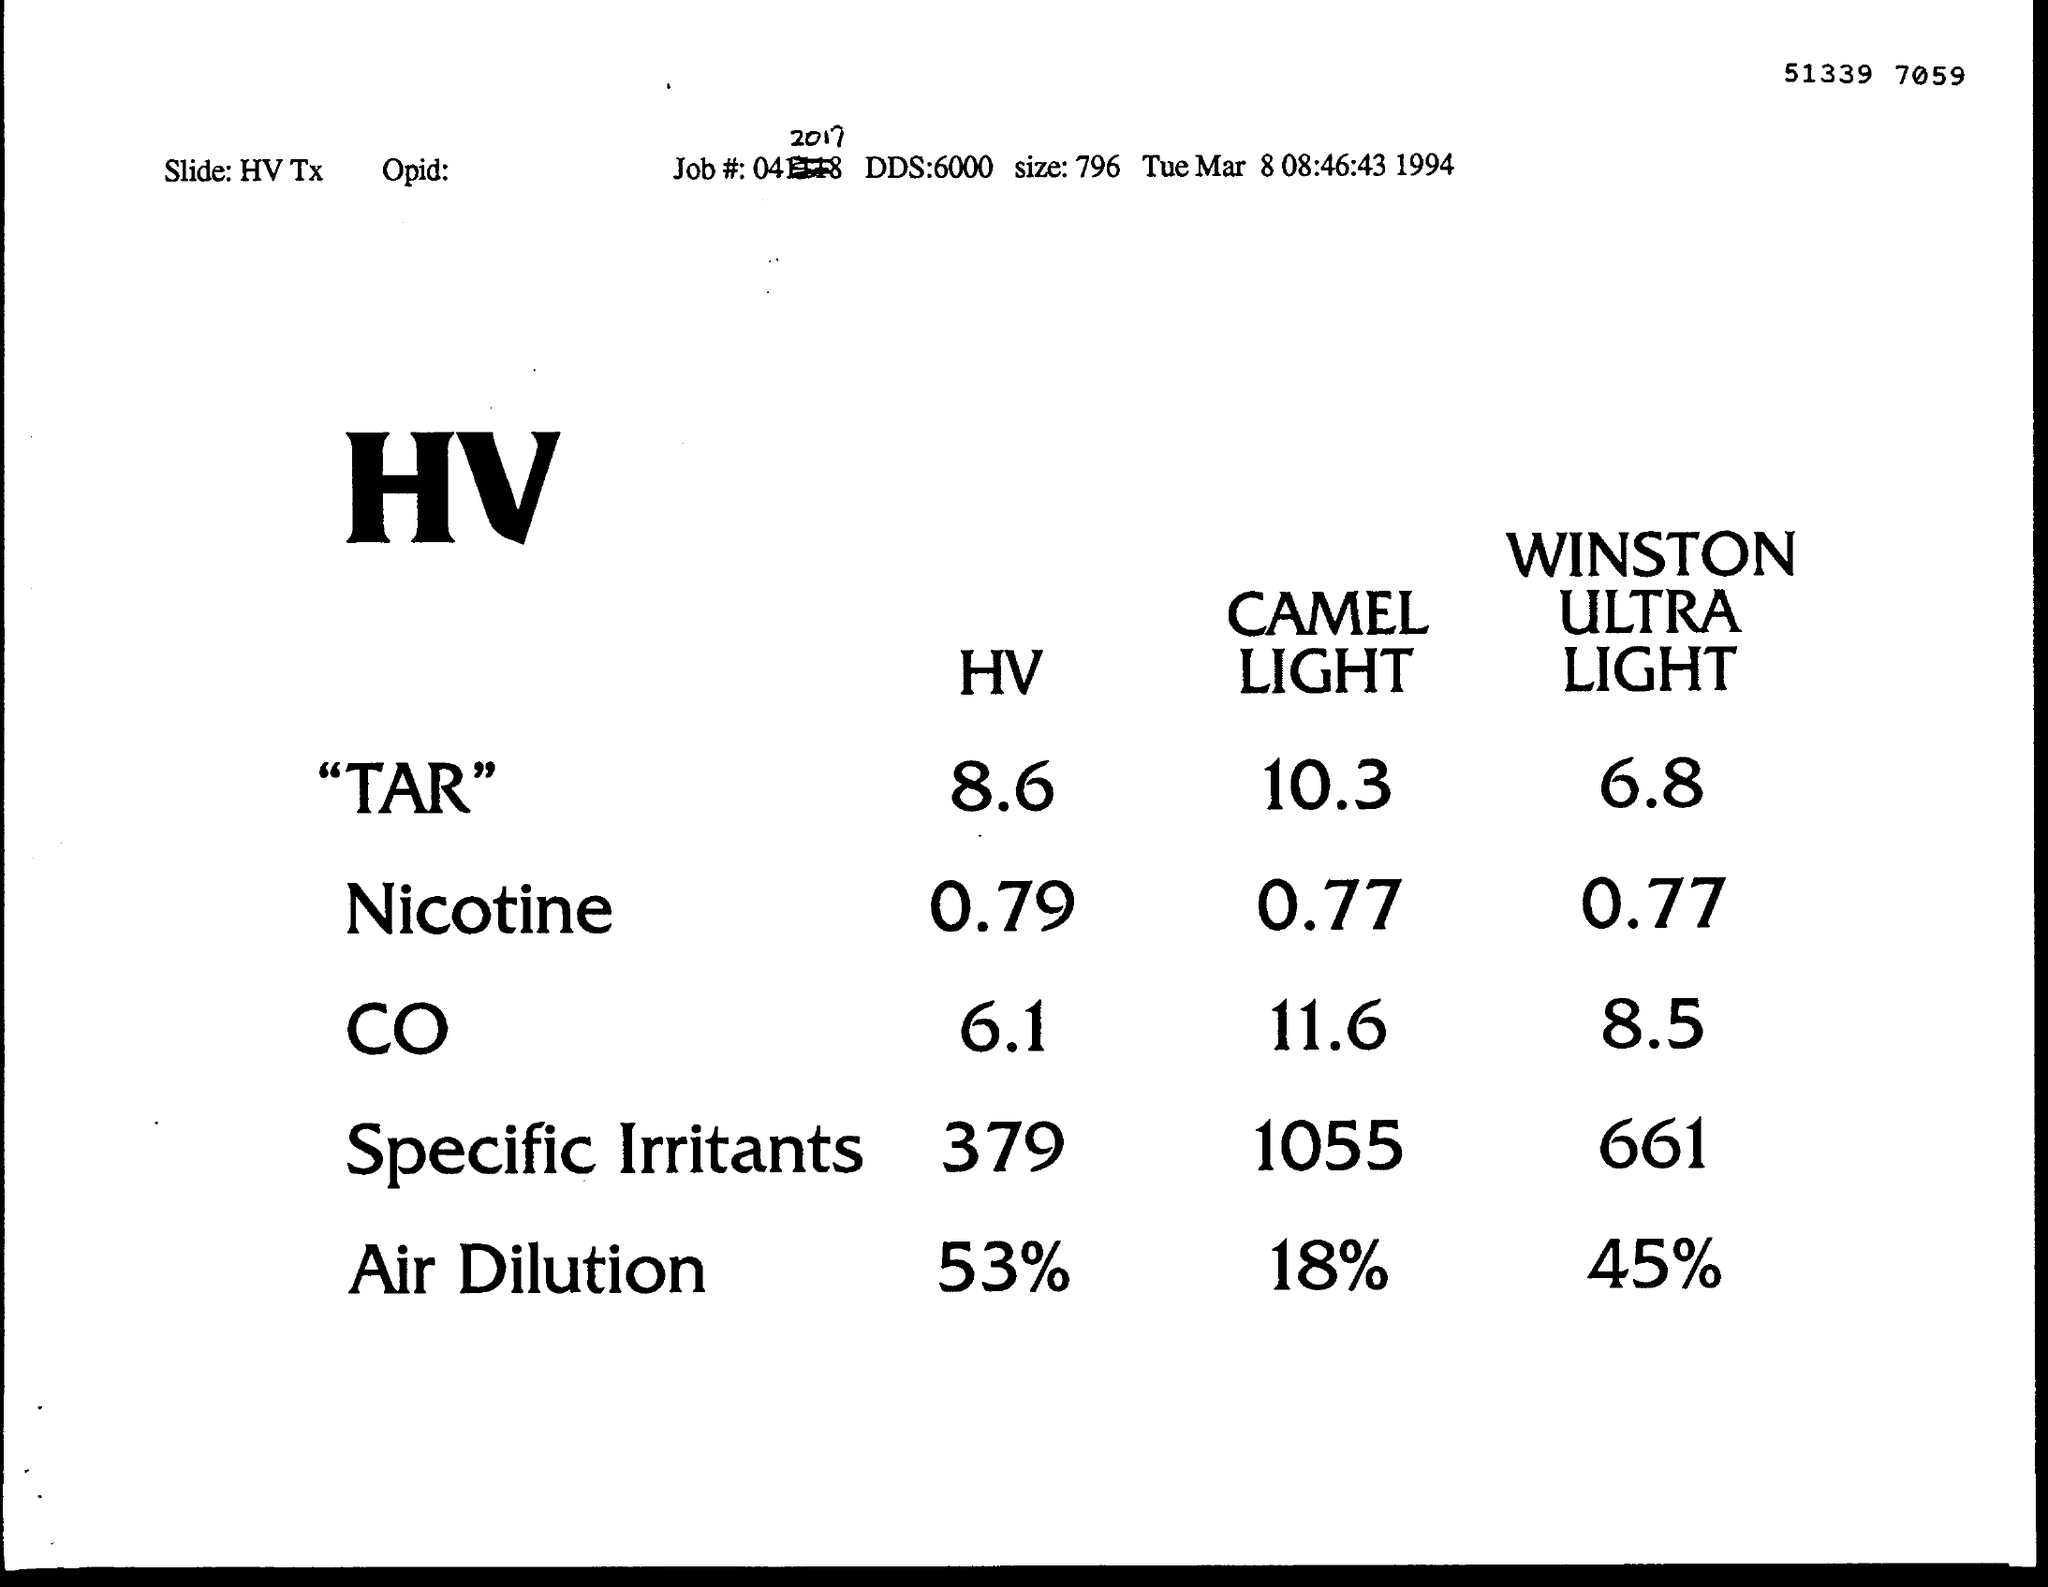What is the size mentioned ?
Offer a terse response. 796. What is the year mentioned ?
Provide a succinct answer. 1994. What is the time mentioned ?
Give a very brief answer. 08:46:43. How much is the hv of air dilution ?
Provide a succinct answer. 53%. How much is the hv for specific irritants ?
Make the answer very short. 379. 